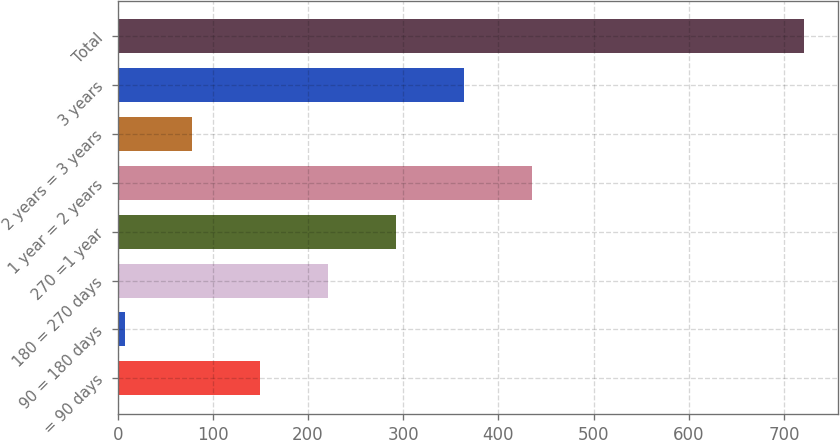Convert chart to OTSL. <chart><loc_0><loc_0><loc_500><loc_500><bar_chart><fcel>= 90 days<fcel>90 = 180 days<fcel>180 = 270 days<fcel>270 =1 year<fcel>1 year = 2 years<fcel>2 years = 3 years<fcel>3 years<fcel>Total<nl><fcel>149.94<fcel>7.2<fcel>221.31<fcel>292.68<fcel>435.42<fcel>78.57<fcel>364.05<fcel>720.9<nl></chart> 